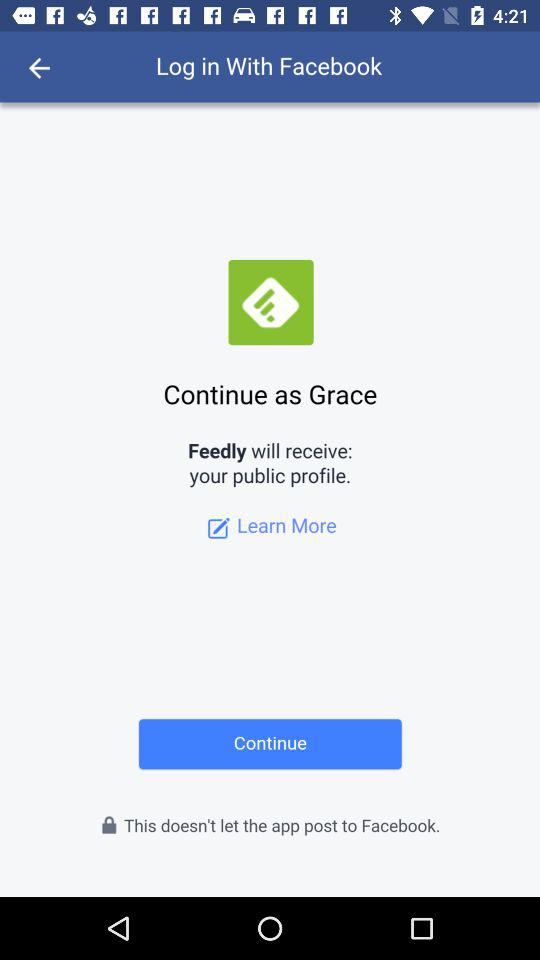What is the user name to continue on the login page? The user name is Grace. 